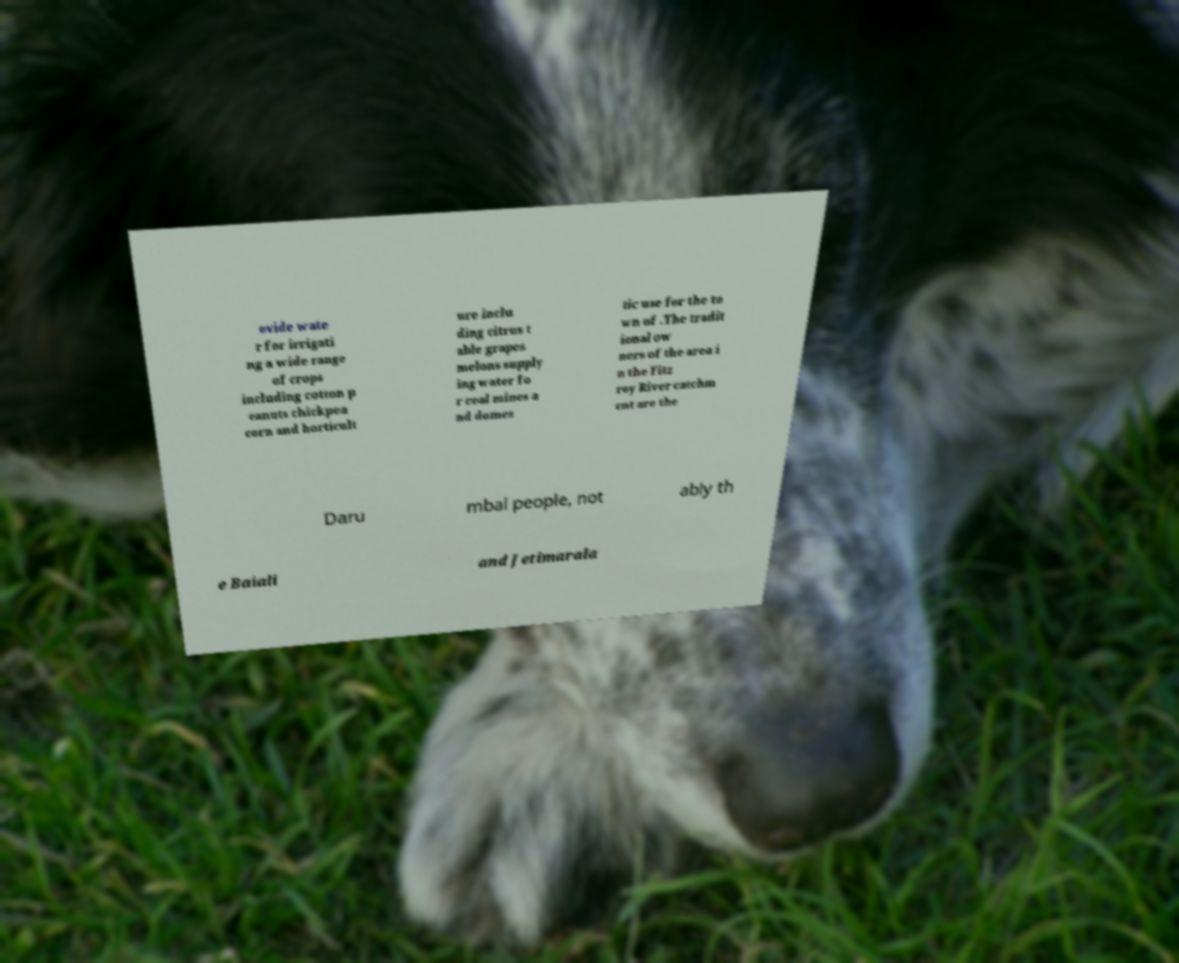Could you assist in decoding the text presented in this image and type it out clearly? ovide wate r for irrigati ng a wide range of crops including cotton p eanuts chickpea corn and horticult ure inclu ding citrus t able grapes melons supply ing water fo r coal mines a nd domes tic use for the to wn of .The tradit ional ow ners of the area i n the Fitz roy River catchm ent are the Daru mbal people, not ably th e Baiali and Jetimarala 